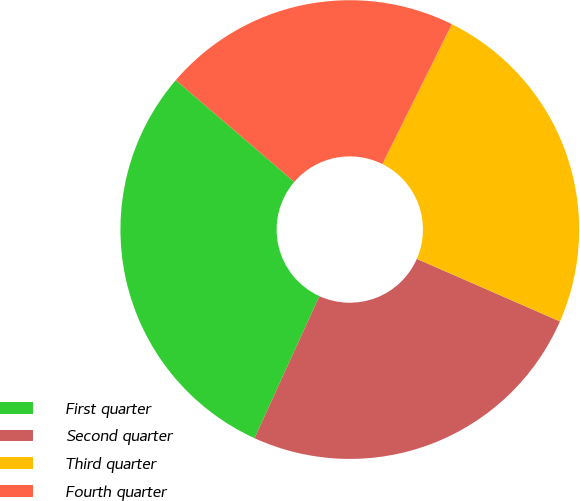Convert chart. <chart><loc_0><loc_0><loc_500><loc_500><pie_chart><fcel>First quarter<fcel>Second quarter<fcel>Third quarter<fcel>Fourth quarter<nl><fcel>29.47%<fcel>25.26%<fcel>24.21%<fcel>21.05%<nl></chart> 